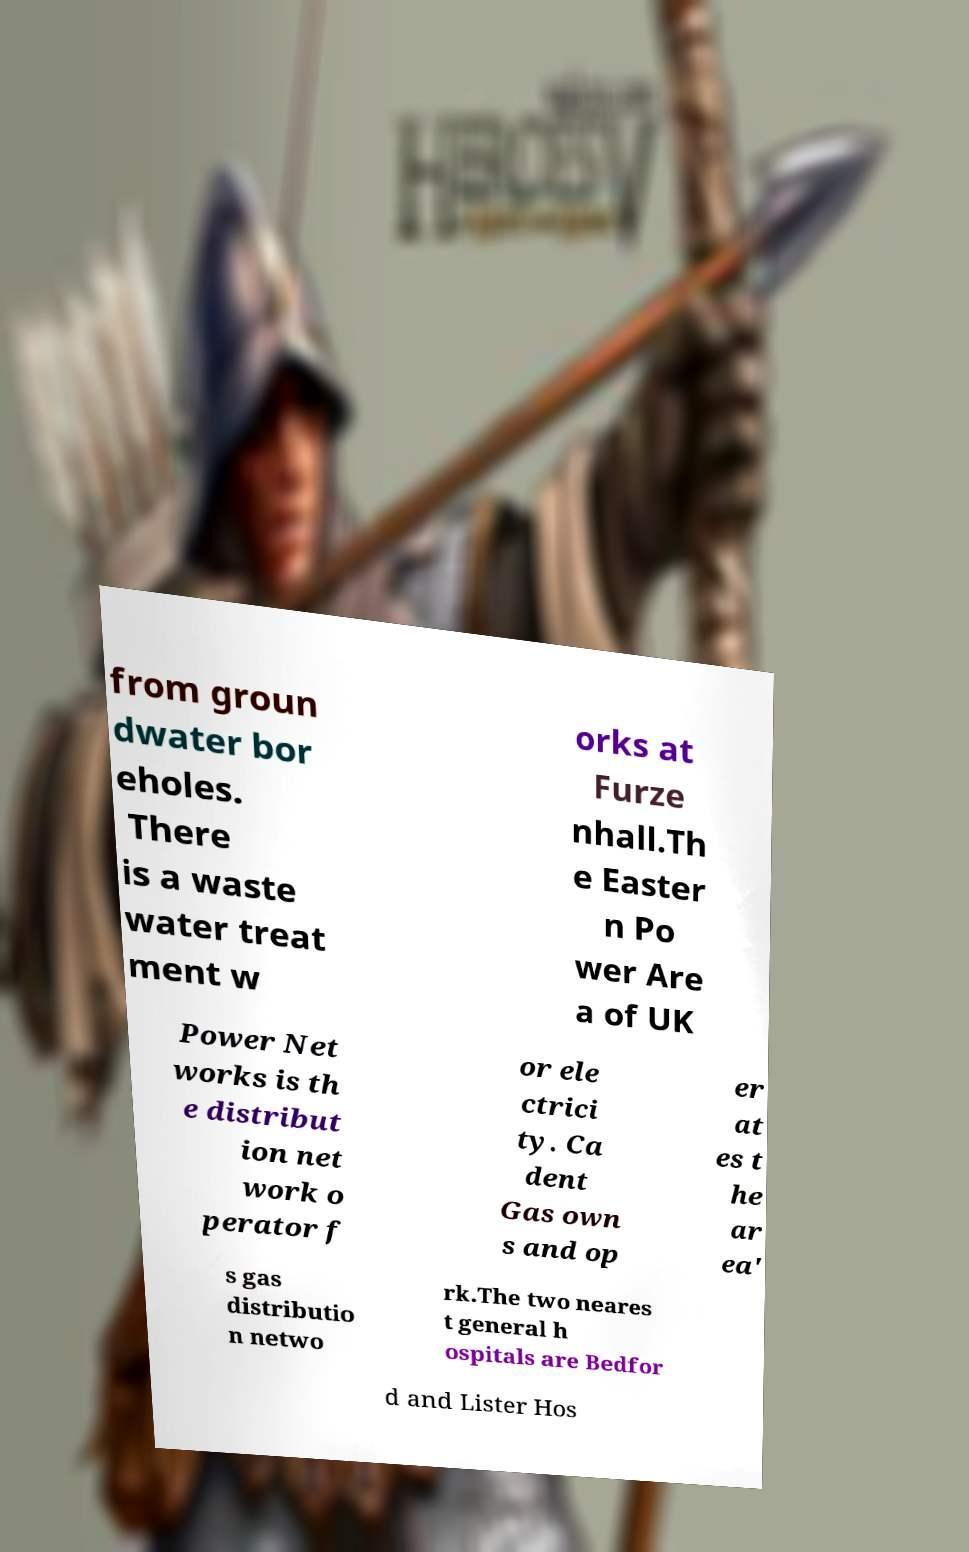What messages or text are displayed in this image? I need them in a readable, typed format. from groun dwater bor eholes. There is a waste water treat ment w orks at Furze nhall.Th e Easter n Po wer Are a of UK Power Net works is th e distribut ion net work o perator f or ele ctrici ty. Ca dent Gas own s and op er at es t he ar ea' s gas distributio n netwo rk.The two neares t general h ospitals are Bedfor d and Lister Hos 